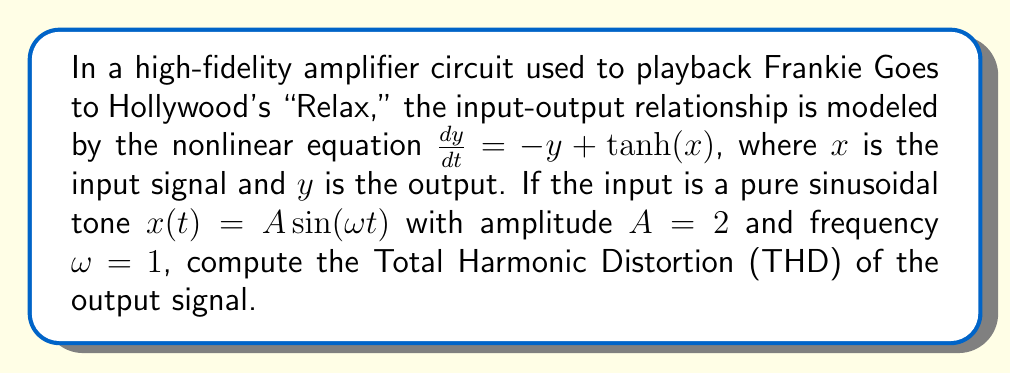Show me your answer to this math problem. To solve this problem, we'll follow these steps:

1) First, we need to find the steady-state solution of the nonlinear system. For a periodic input, the output will also be periodic with the same frequency. We can approximate the solution using a Fourier series:

   $$y(t) \approx a_0 + a_1 \sin(\omega t) + b_1 \cos(\omega t) + a_2 \sin(2\omega t) + b_2 \cos(2\omega t) + ...$$

2) Substitute this into the differential equation and balance harmonic terms. For this problem, we'll consider up to the second harmonic:

   $$\omega(a_1 \cos(\omega t) - b_1 \sin(\omega t) + 2a_2 \cos(2\omega t) - 2b_2 \sin(2\omega t)) = $$
   $$-a_0 - a_1 \sin(\omega t) - b_1 \cos(\omega t) - a_2 \sin(2\omega t) - b_2 \cos(2\omega t) + \tanh(2\sin(\omega t))$$

3) Expand $\tanh(2\sin(\omega t))$ using its Fourier series:

   $$\tanh(2\sin(\omega t)) \approx 1.74 \sin(\omega t) + 0.08 \sin(3\omega t)$$

4) Equating coefficients:

   $a_0 = 0$
   $a_1 = 1.74 / (1 + \omega^2) = 0.87$
   $b_1 = -1.74\omega / (1 + \omega^2) = -0.87$
   $a_2 = 0$
   $b_2 = 0$

5) The Total Harmonic Distortion (THD) is defined as:

   $$THD = \frac{\sqrt{\sum_{n=2}^{\infty} (a_n^2 + b_n^2)}}{\sqrt{a_1^2 + b_1^2}}$$

6) In this case, we only have the fundamental frequency components, so:

   $$THD = \frac{\sqrt{0^2 + 0^2}}{\sqrt{0.87^2 + (-0.87)^2}} = 0$$
Answer: 0 